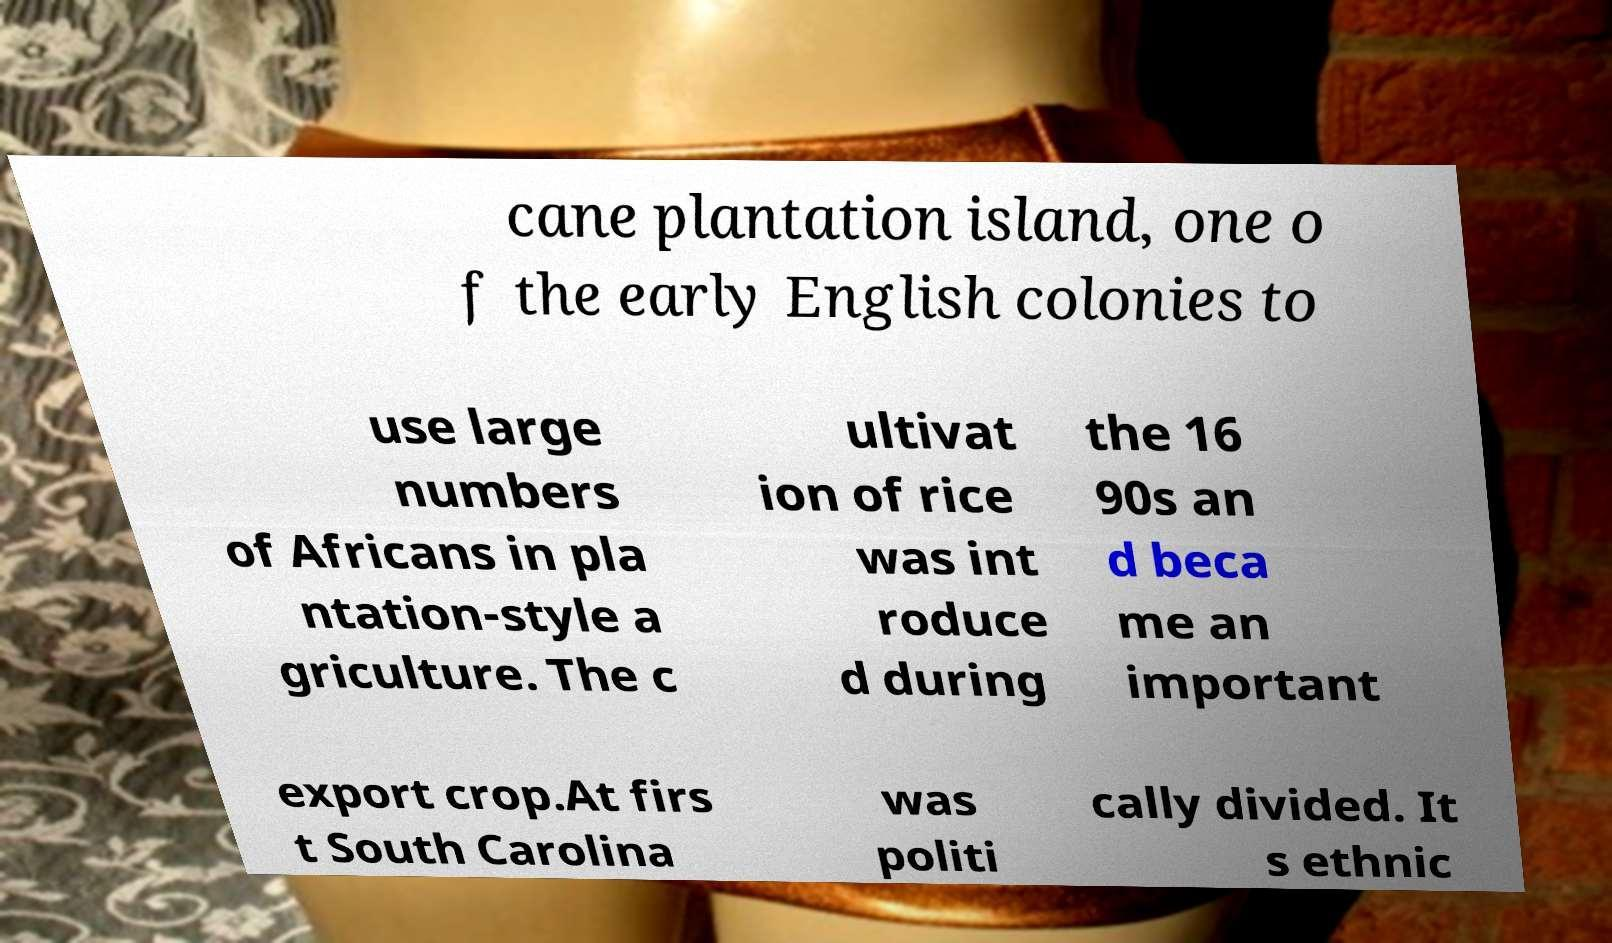What messages or text are displayed in this image? I need them in a readable, typed format. cane plantation island, one o f the early English colonies to use large numbers of Africans in pla ntation-style a griculture. The c ultivat ion of rice was int roduce d during the 16 90s an d beca me an important export crop.At firs t South Carolina was politi cally divided. It s ethnic 